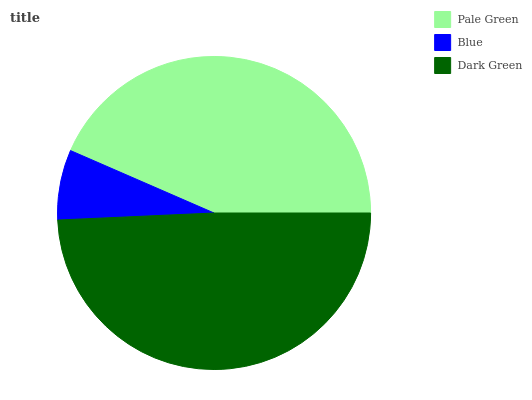Is Blue the minimum?
Answer yes or no. Yes. Is Dark Green the maximum?
Answer yes or no. Yes. Is Dark Green the minimum?
Answer yes or no. No. Is Blue the maximum?
Answer yes or no. No. Is Dark Green greater than Blue?
Answer yes or no. Yes. Is Blue less than Dark Green?
Answer yes or no. Yes. Is Blue greater than Dark Green?
Answer yes or no. No. Is Dark Green less than Blue?
Answer yes or no. No. Is Pale Green the high median?
Answer yes or no. Yes. Is Pale Green the low median?
Answer yes or no. Yes. Is Blue the high median?
Answer yes or no. No. Is Blue the low median?
Answer yes or no. No. 